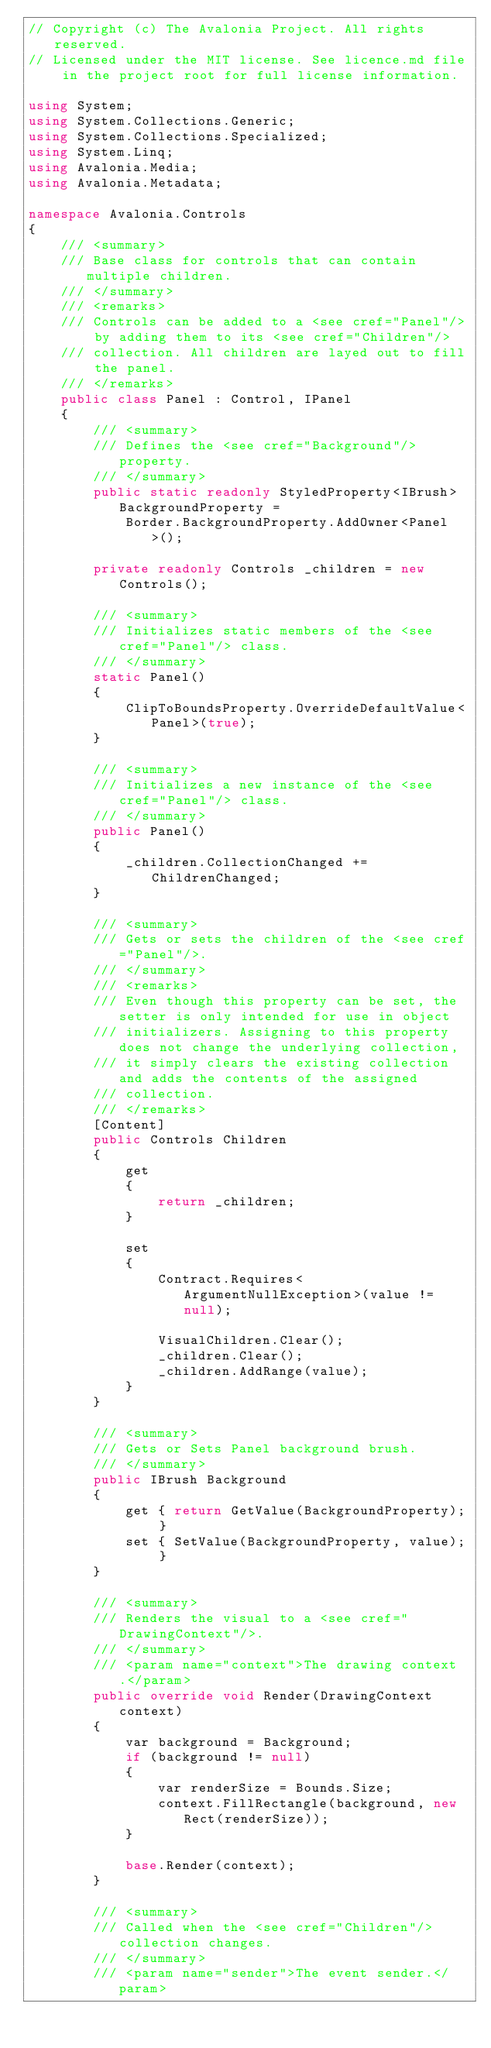<code> <loc_0><loc_0><loc_500><loc_500><_C#_>// Copyright (c) The Avalonia Project. All rights reserved.
// Licensed under the MIT license. See licence.md file in the project root for full license information.

using System;
using System.Collections.Generic;
using System.Collections.Specialized;
using System.Linq;
using Avalonia.Media;
using Avalonia.Metadata;

namespace Avalonia.Controls
{
    /// <summary>
    /// Base class for controls that can contain multiple children.
    /// </summary>
    /// <remarks>
    /// Controls can be added to a <see cref="Panel"/> by adding them to its <see cref="Children"/>
    /// collection. All children are layed out to fill the panel.
    /// </remarks>
    public class Panel : Control, IPanel
    {
        /// <summary>
        /// Defines the <see cref="Background"/> property.
        /// </summary>
        public static readonly StyledProperty<IBrush> BackgroundProperty =
            Border.BackgroundProperty.AddOwner<Panel>();

        private readonly Controls _children = new Controls();

        /// <summary>
        /// Initializes static members of the <see cref="Panel"/> class.
        /// </summary>
        static Panel()
        {
            ClipToBoundsProperty.OverrideDefaultValue<Panel>(true);
        }

        /// <summary>
        /// Initializes a new instance of the <see cref="Panel"/> class.
        /// </summary>
        public Panel()
        {
            _children.CollectionChanged += ChildrenChanged;
        }

        /// <summary>
        /// Gets or sets the children of the <see cref="Panel"/>.
        /// </summary>
        /// <remarks>
        /// Even though this property can be set, the setter is only intended for use in object
        /// initializers. Assigning to this property does not change the underlying collection,
        /// it simply clears the existing collection and adds the contents of the assigned
        /// collection.
        /// </remarks>
        [Content]
        public Controls Children
        {
            get
            {
                return _children;
            }

            set
            {
                Contract.Requires<ArgumentNullException>(value != null);

                VisualChildren.Clear();
                _children.Clear();
                _children.AddRange(value);
            }
        }

        /// <summary>
        /// Gets or Sets Panel background brush.
        /// </summary>
        public IBrush Background
        {
            get { return GetValue(BackgroundProperty); }
            set { SetValue(BackgroundProperty, value); }
        }

        /// <summary>
        /// Renders the visual to a <see cref="DrawingContext"/>.
        /// </summary>
        /// <param name="context">The drawing context.</param>
        public override void Render(DrawingContext context)
        {
            var background = Background;
            if (background != null)
            {
                var renderSize = Bounds.Size;
                context.FillRectangle(background, new Rect(renderSize));
            }

            base.Render(context);
        }

        /// <summary>
        /// Called when the <see cref="Children"/> collection changes.
        /// </summary>
        /// <param name="sender">The event sender.</param></code> 